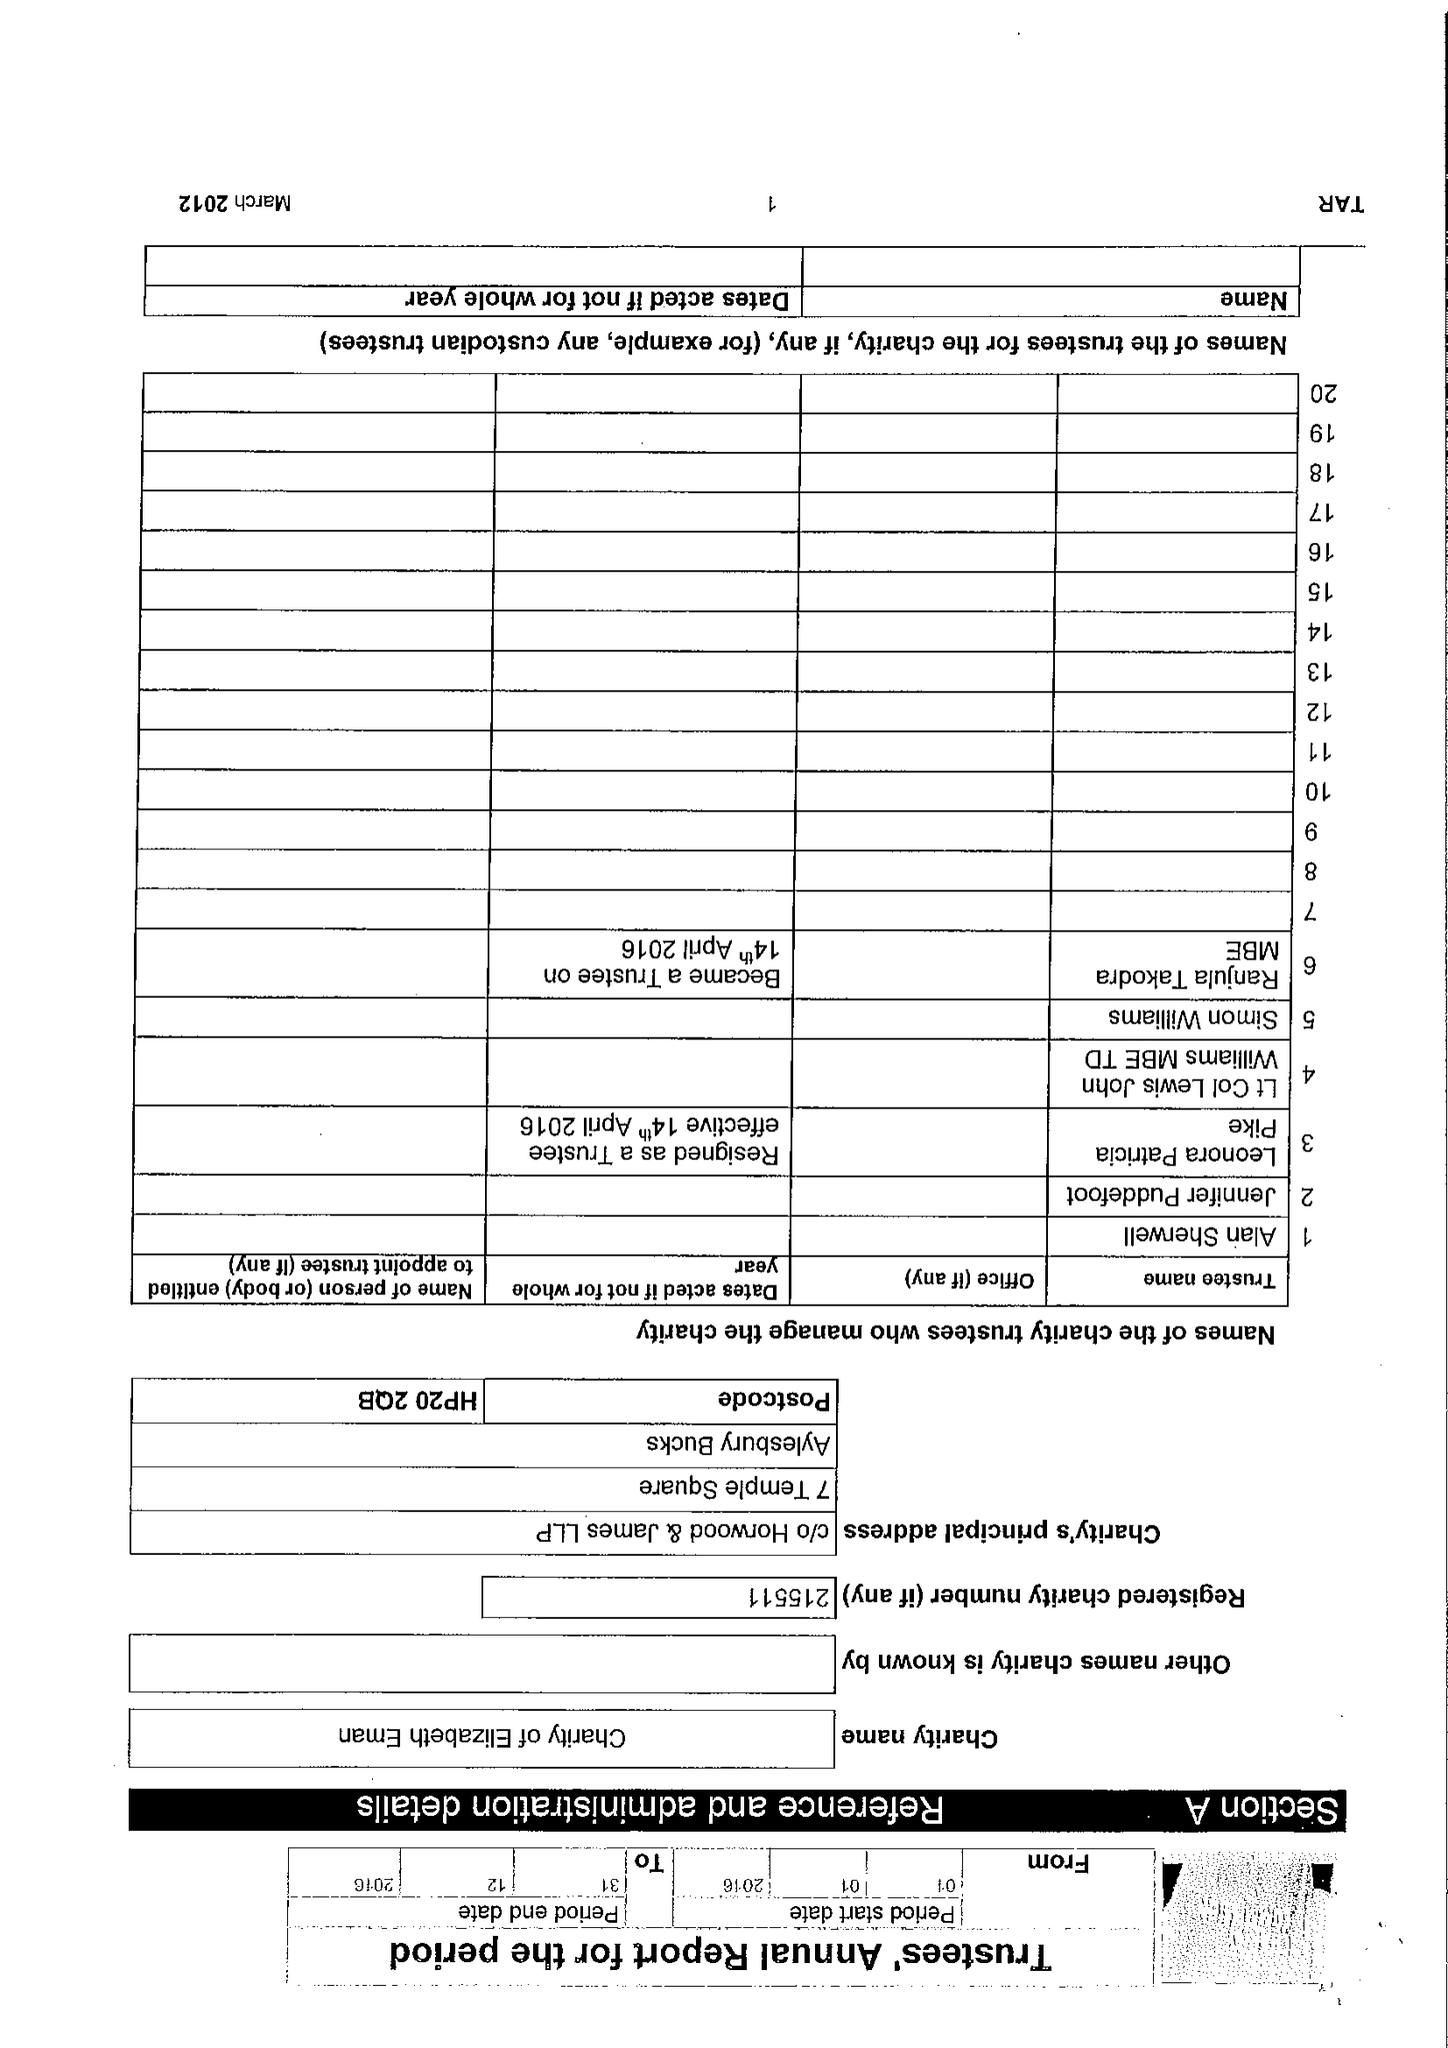What is the value for the charity_number?
Answer the question using a single word or phrase. 215511 